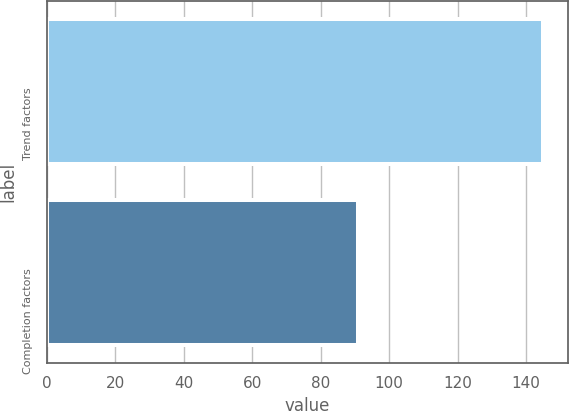Convert chart. <chart><loc_0><loc_0><loc_500><loc_500><bar_chart><fcel>Trend factors<fcel>Completion factors<nl><fcel>145<fcel>91<nl></chart> 